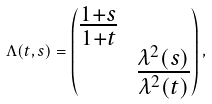Convert formula to latex. <formula><loc_0><loc_0><loc_500><loc_500>\Lambda ( t , s ) = \begin{pmatrix} \frac { 1 + s } { 1 + t } & \\ & \frac { \lambda ^ { 2 } ( s ) } { \lambda ^ { 2 } ( t ) } \end{pmatrix} ,</formula> 